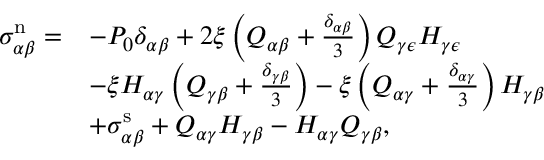Convert formula to latex. <formula><loc_0><loc_0><loc_500><loc_500>\begin{array} { r l } { \sigma _ { \alpha \beta } ^ { n } = } & { - P _ { 0 } \delta _ { \alpha \beta } + 2 \xi \left ( Q _ { \alpha \beta } + \frac { \delta _ { \alpha \beta } } { 3 } \right ) Q _ { \gamma \epsilon } H _ { \gamma \epsilon } } \\ & { - \xi H _ { \alpha \gamma } \left ( Q _ { \gamma \beta } + \frac { \delta _ { \gamma \beta } } { 3 } \right ) - \xi \left ( Q _ { \alpha \gamma } + \frac { \delta _ { \alpha \gamma } } { 3 } \right ) H _ { \gamma \beta } } \\ & { + \sigma _ { \alpha \beta } ^ { s } + Q _ { \alpha \gamma } H _ { \gamma \beta } - H _ { \alpha \gamma } Q _ { \gamma \beta } , } \end{array}</formula> 